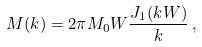Convert formula to latex. <formula><loc_0><loc_0><loc_500><loc_500>M ( k ) = 2 \pi M _ { 0 } W \frac { J _ { 1 } ( k W ) } { k } \, ,</formula> 